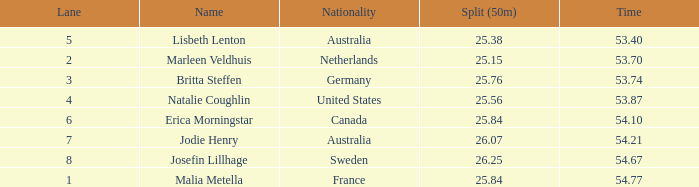74 in a lane of under 3? None. 